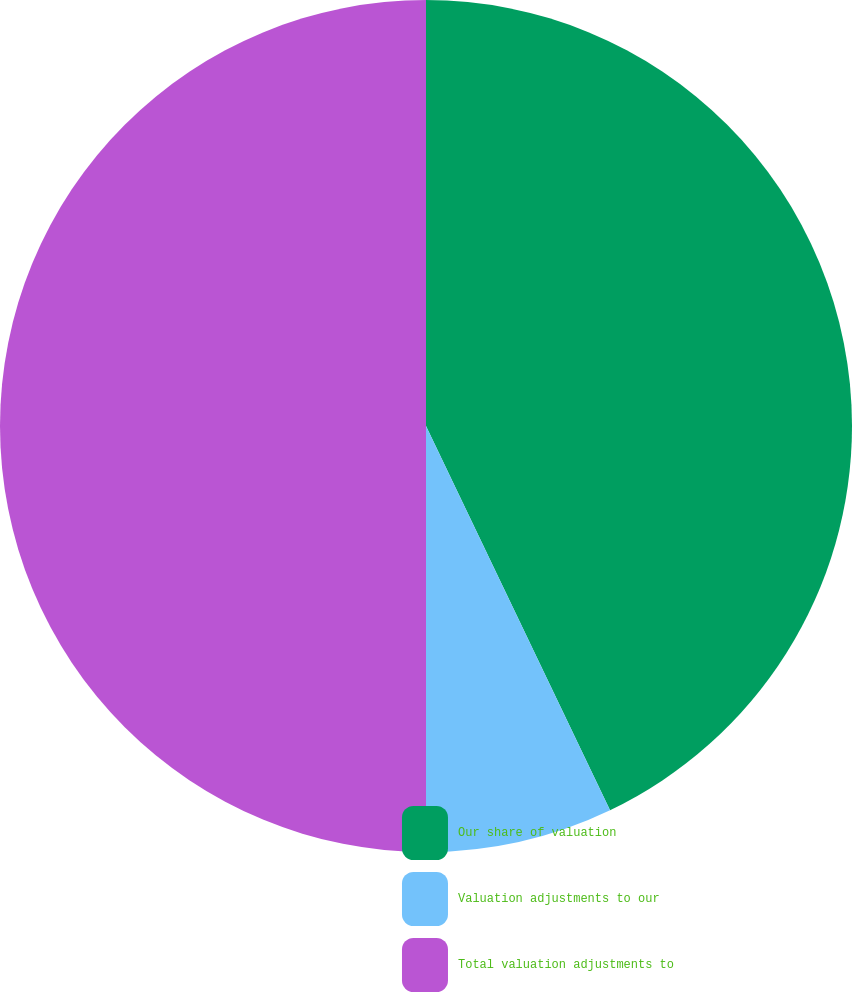Convert chart to OTSL. <chart><loc_0><loc_0><loc_500><loc_500><pie_chart><fcel>Our share of valuation<fcel>Valuation adjustments to our<fcel>Total valuation adjustments to<nl><fcel>42.89%<fcel>7.11%<fcel>50.0%<nl></chart> 